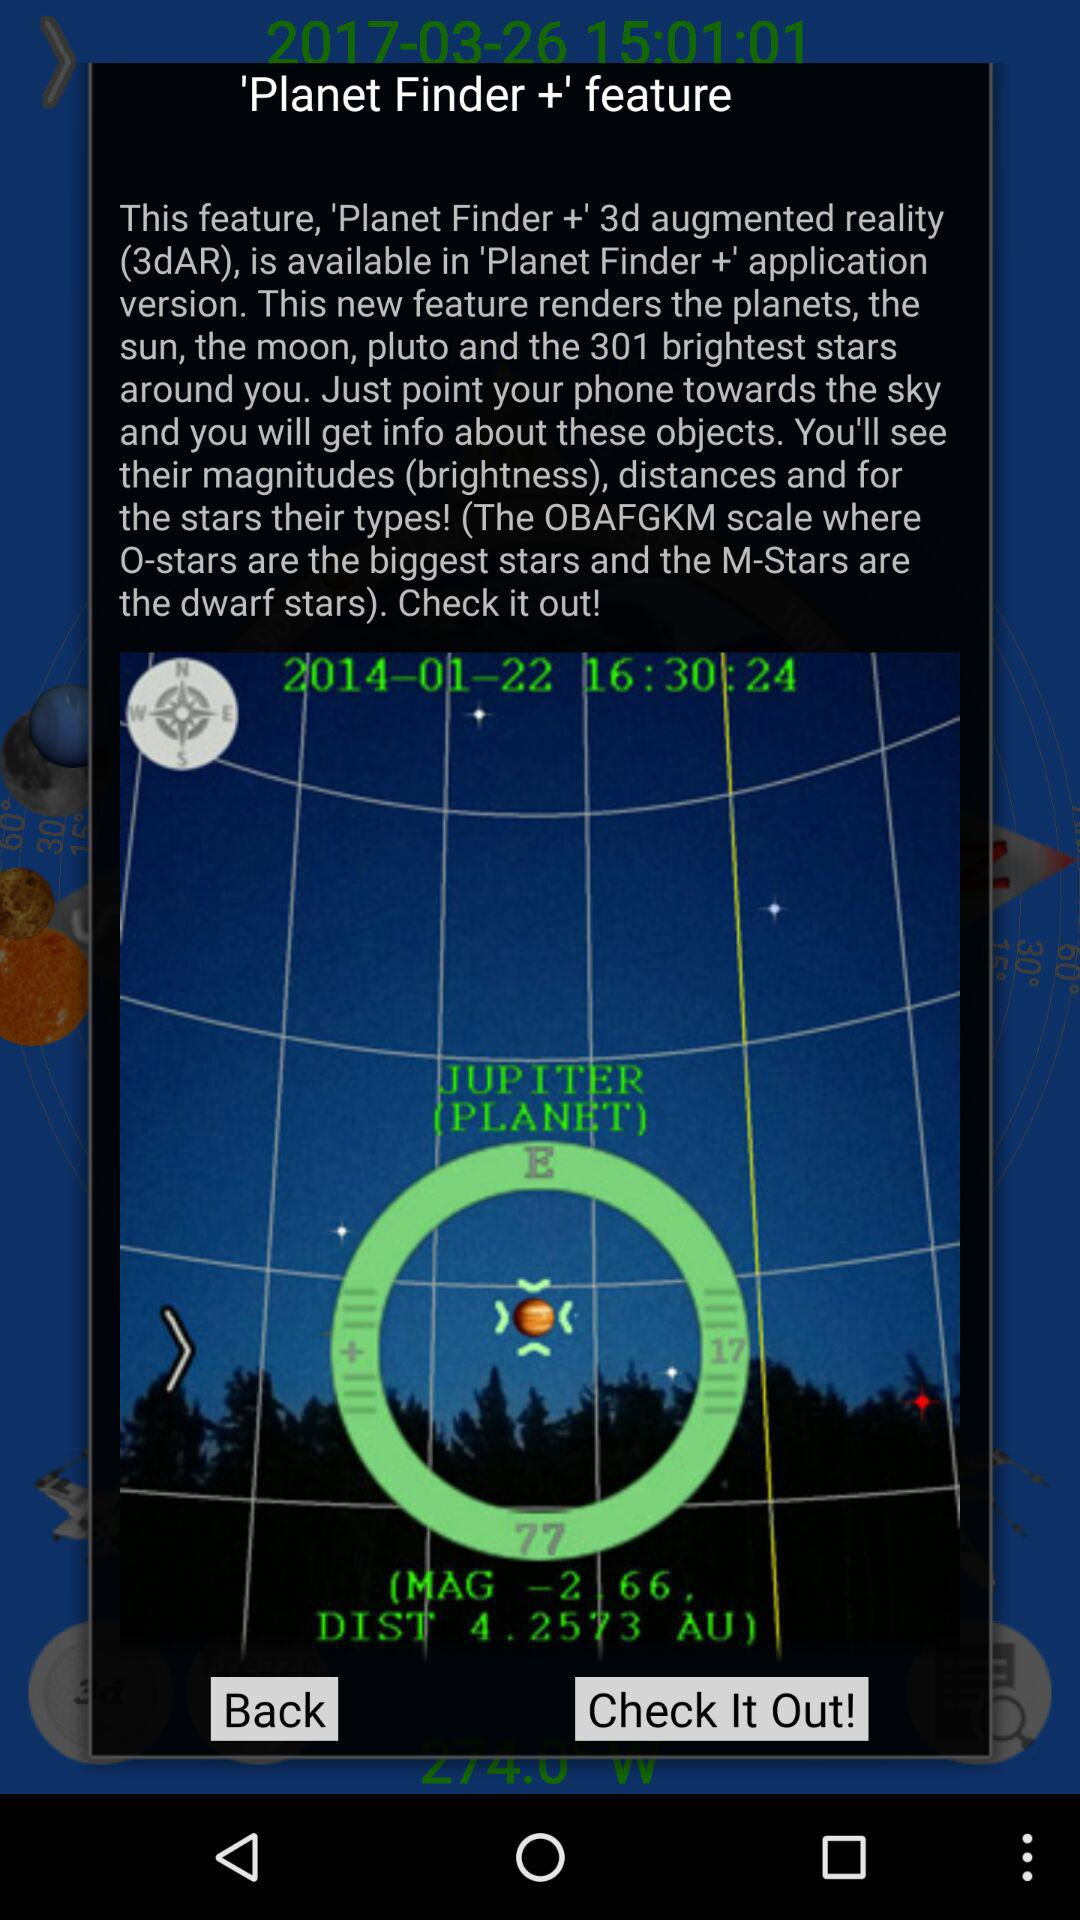What is the mentioned date and time? The mentioned date and time are January 22, 2014 and 16:30:24 respectively. 